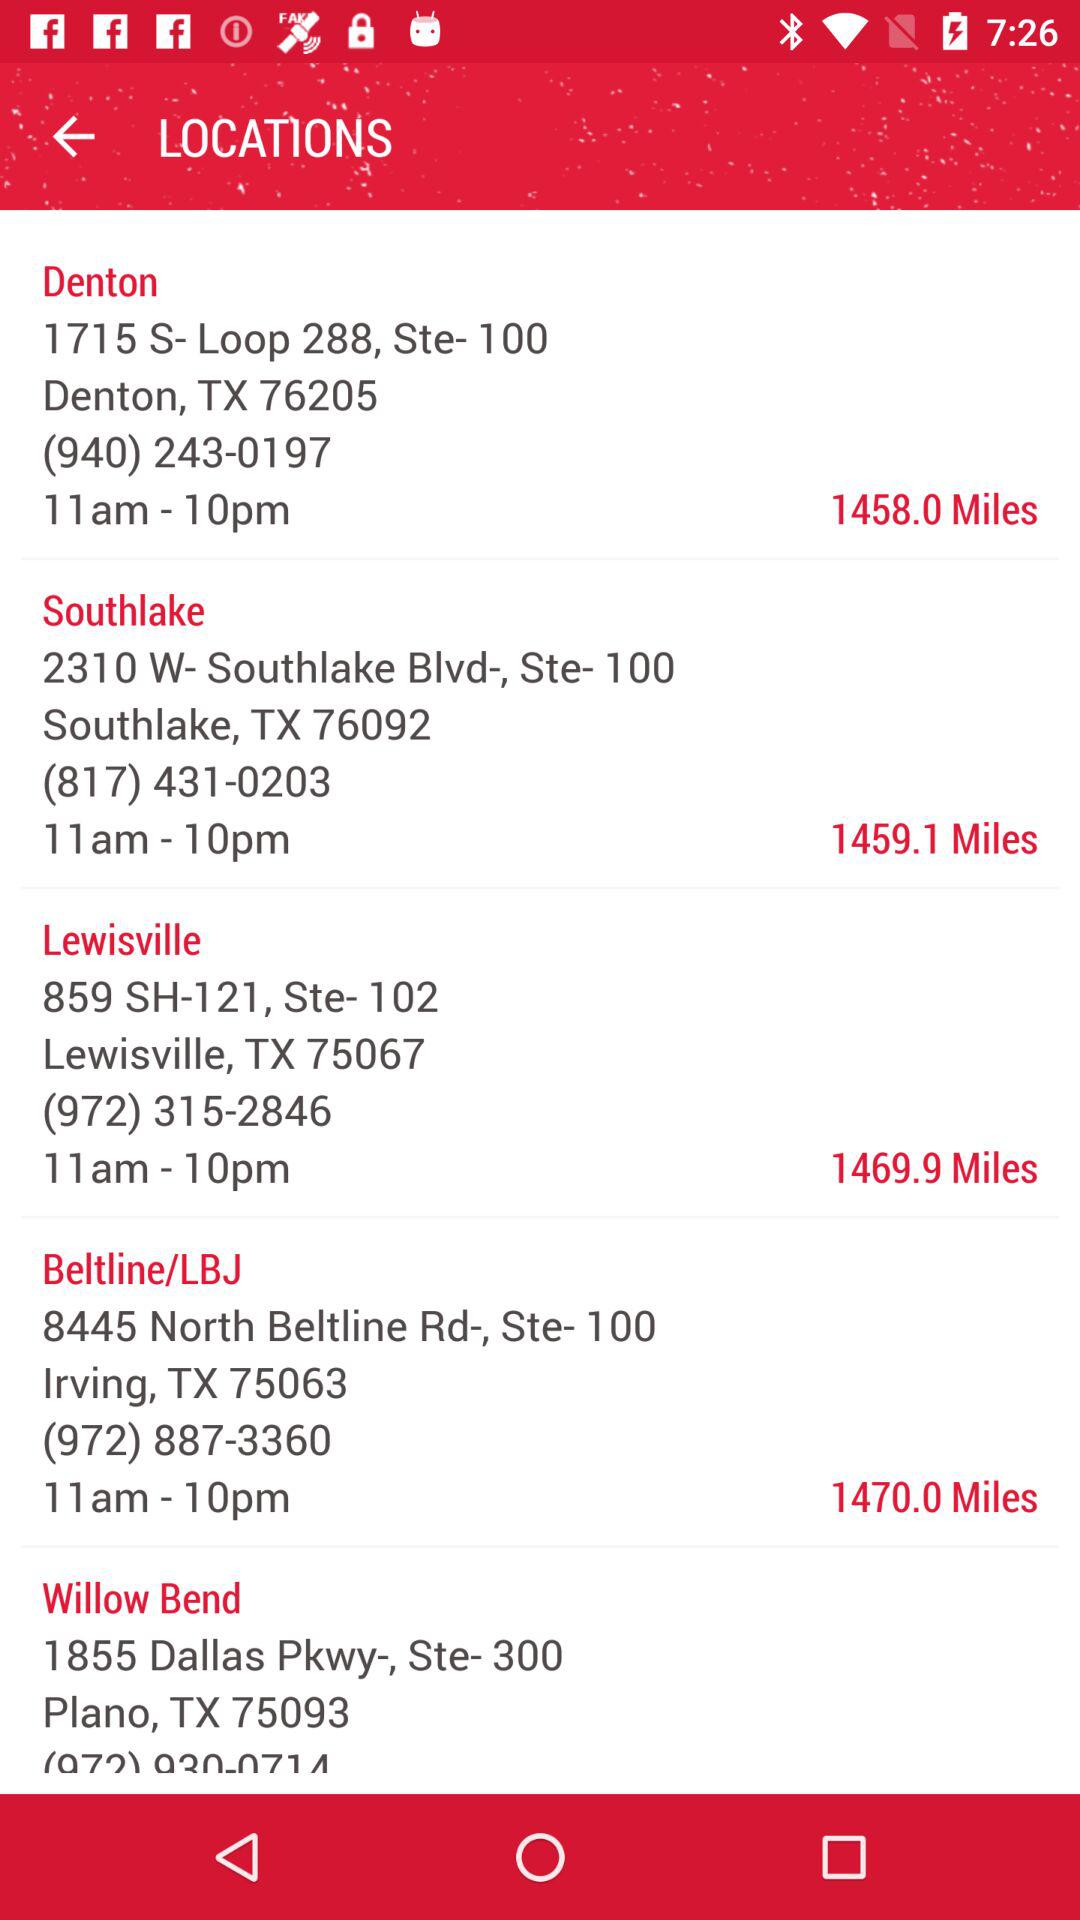What is the address of Denton? The address is 1715 S- Loop 288, Ste- 100 Denton, TX 76205. 